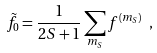<formula> <loc_0><loc_0><loc_500><loc_500>\tilde { f } _ { 0 } = \frac { 1 } { 2 S + 1 } \sum _ { m _ { S } } f ^ { ( m _ { S } ) } \ ,</formula> 